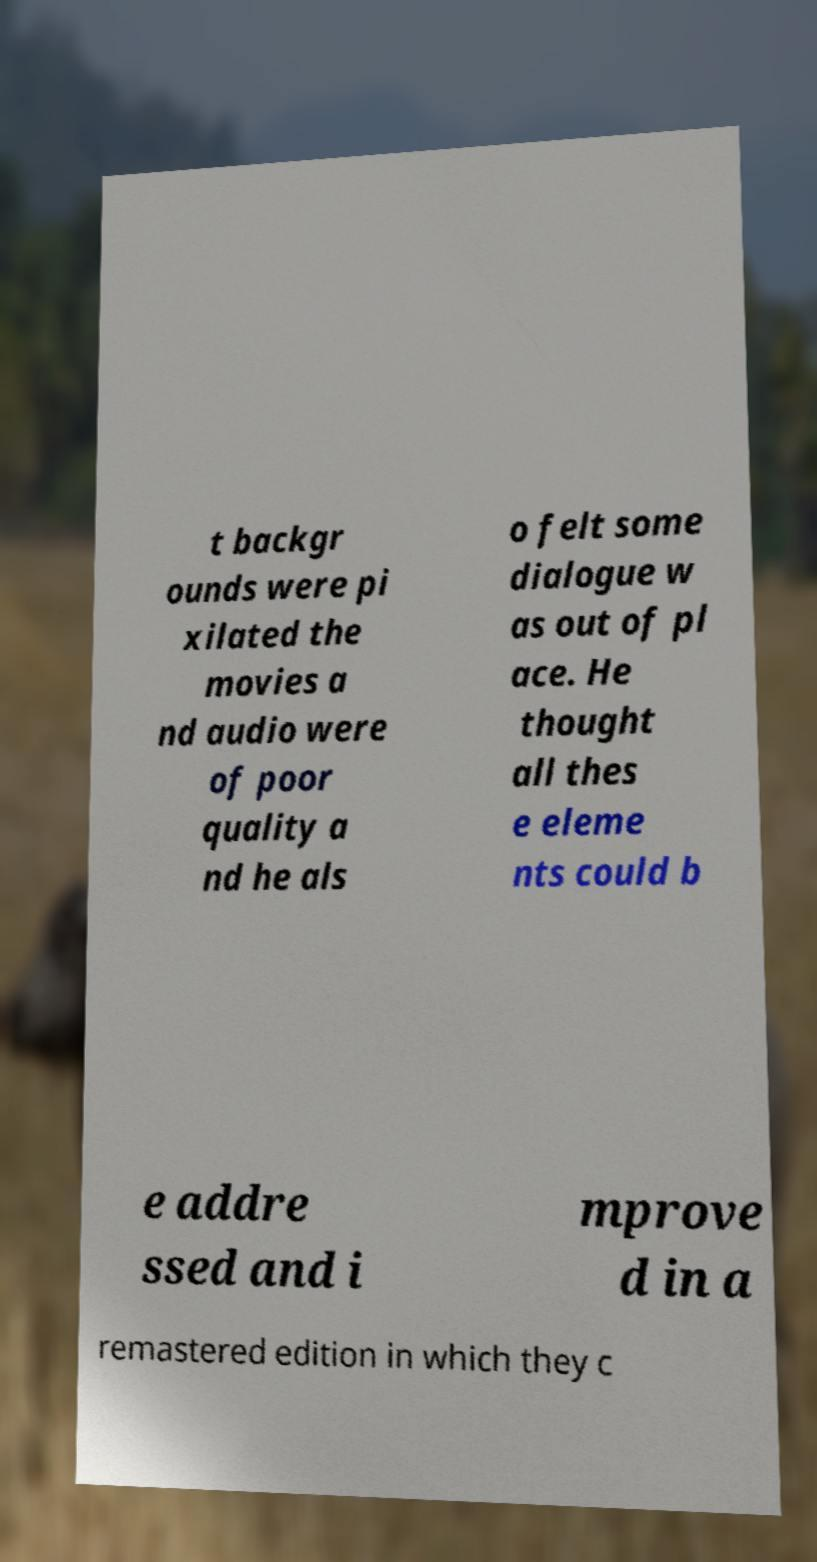Please identify and transcribe the text found in this image. t backgr ounds were pi xilated the movies a nd audio were of poor quality a nd he als o felt some dialogue w as out of pl ace. He thought all thes e eleme nts could b e addre ssed and i mprove d in a remastered edition in which they c 